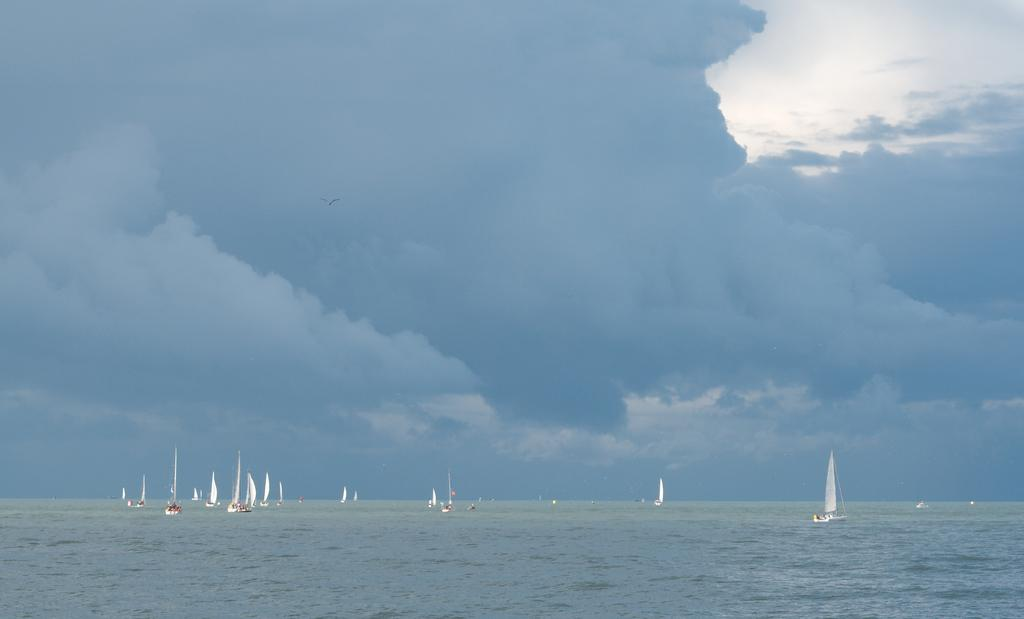What can be seen at the bottom of the image? There are boats in the sea at the bottom of the image. What is visible in the background of the image? The background of the image includes clouds. What part of the natural environment is visible in the image? The sky is visible in the background of the image. What type of condition is the curtain experiencing in the image? There is no curtain present in the image. What role does the minister play in the image? There is no minister present in the image. 